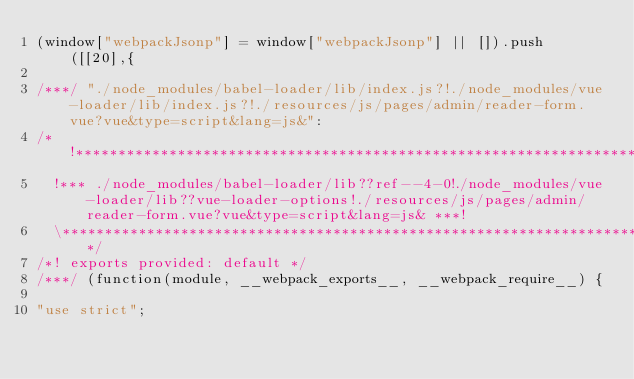Convert code to text. <code><loc_0><loc_0><loc_500><loc_500><_JavaScript_>(window["webpackJsonp"] = window["webpackJsonp"] || []).push([[20],{

/***/ "./node_modules/babel-loader/lib/index.js?!./node_modules/vue-loader/lib/index.js?!./resources/js/pages/admin/reader-form.vue?vue&type=script&lang=js&":
/*!***********************************************************************************************************************************************************************!*\
  !*** ./node_modules/babel-loader/lib??ref--4-0!./node_modules/vue-loader/lib??vue-loader-options!./resources/js/pages/admin/reader-form.vue?vue&type=script&lang=js& ***!
  \***********************************************************************************************************************************************************************/
/*! exports provided: default */
/***/ (function(module, __webpack_exports__, __webpack_require__) {

"use strict";</code> 